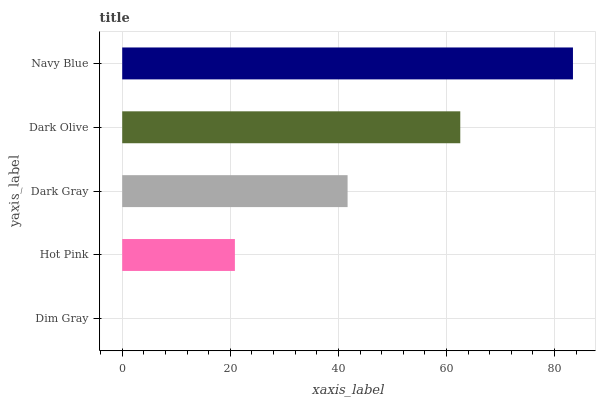Is Dim Gray the minimum?
Answer yes or no. Yes. Is Navy Blue the maximum?
Answer yes or no. Yes. Is Hot Pink the minimum?
Answer yes or no. No. Is Hot Pink the maximum?
Answer yes or no. No. Is Hot Pink greater than Dim Gray?
Answer yes or no. Yes. Is Dim Gray less than Hot Pink?
Answer yes or no. Yes. Is Dim Gray greater than Hot Pink?
Answer yes or no. No. Is Hot Pink less than Dim Gray?
Answer yes or no. No. Is Dark Gray the high median?
Answer yes or no. Yes. Is Dark Gray the low median?
Answer yes or no. Yes. Is Navy Blue the high median?
Answer yes or no. No. Is Hot Pink the low median?
Answer yes or no. No. 